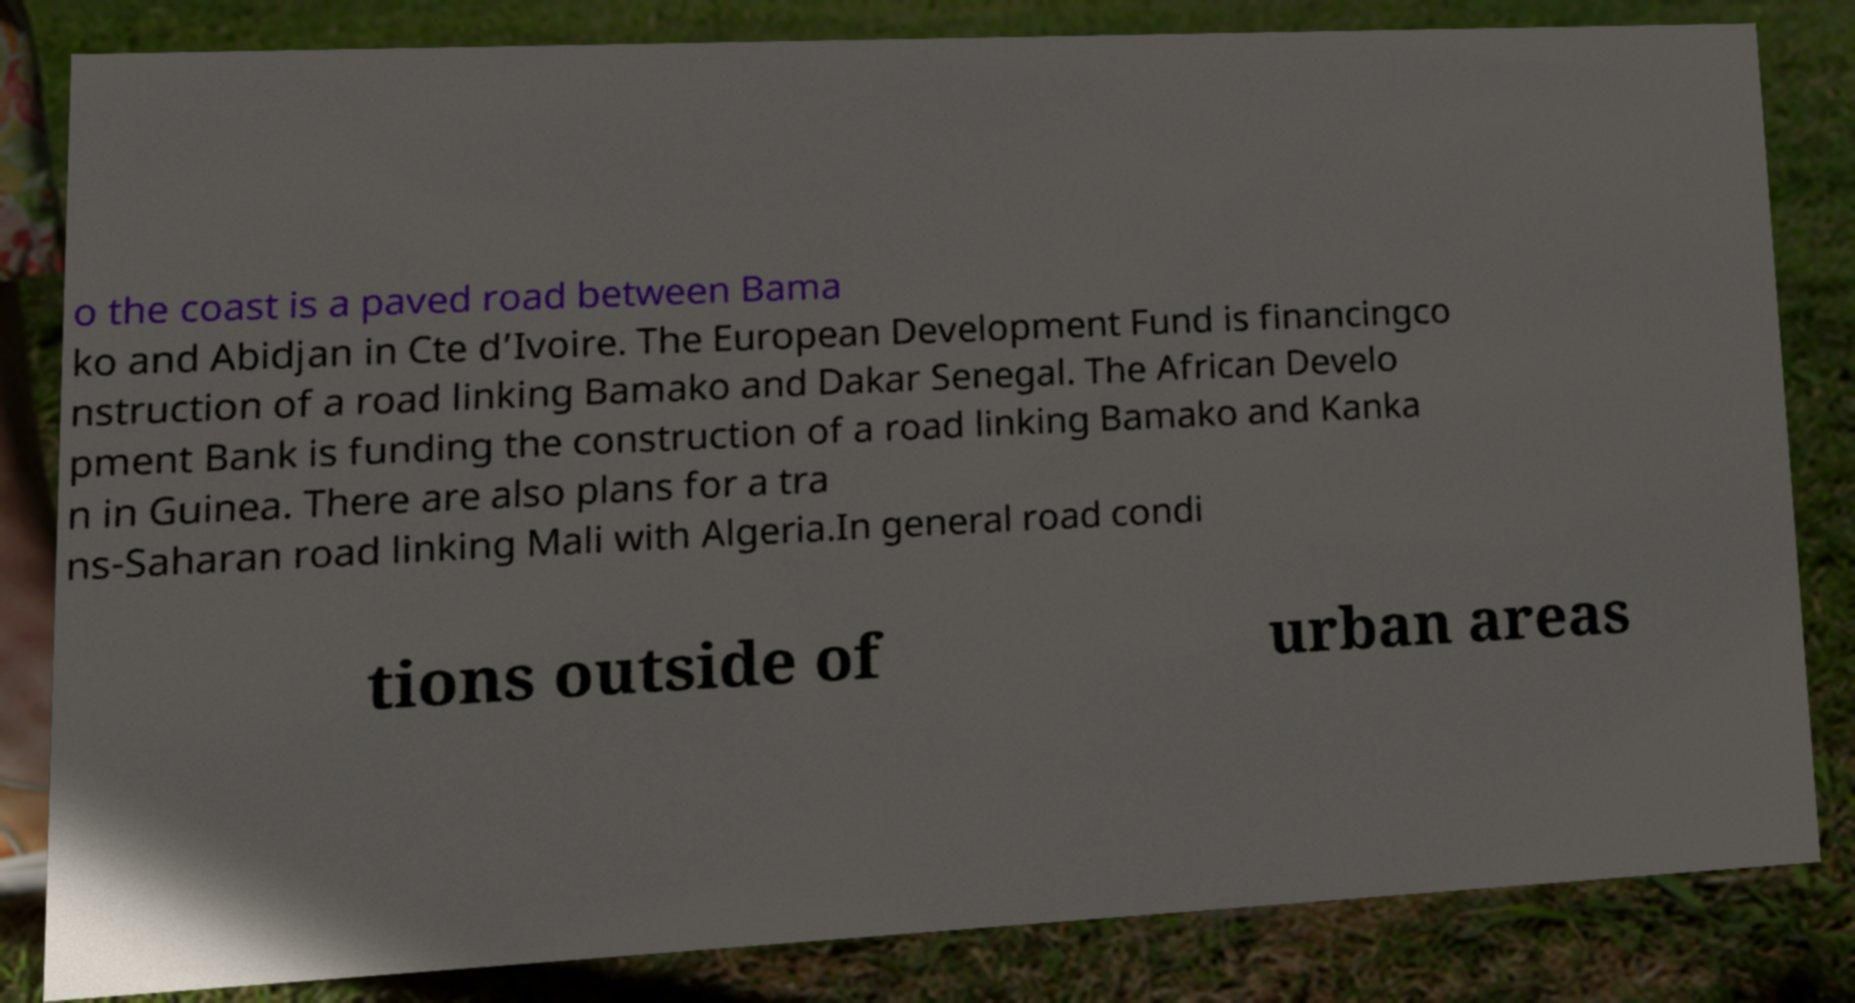Could you extract and type out the text from this image? o the coast is a paved road between Bama ko and Abidjan in Cte d’Ivoire. The European Development Fund is financingco nstruction of a road linking Bamako and Dakar Senegal. The African Develo pment Bank is funding the construction of a road linking Bamako and Kanka n in Guinea. There are also plans for a tra ns-Saharan road linking Mali with Algeria.In general road condi tions outside of urban areas 